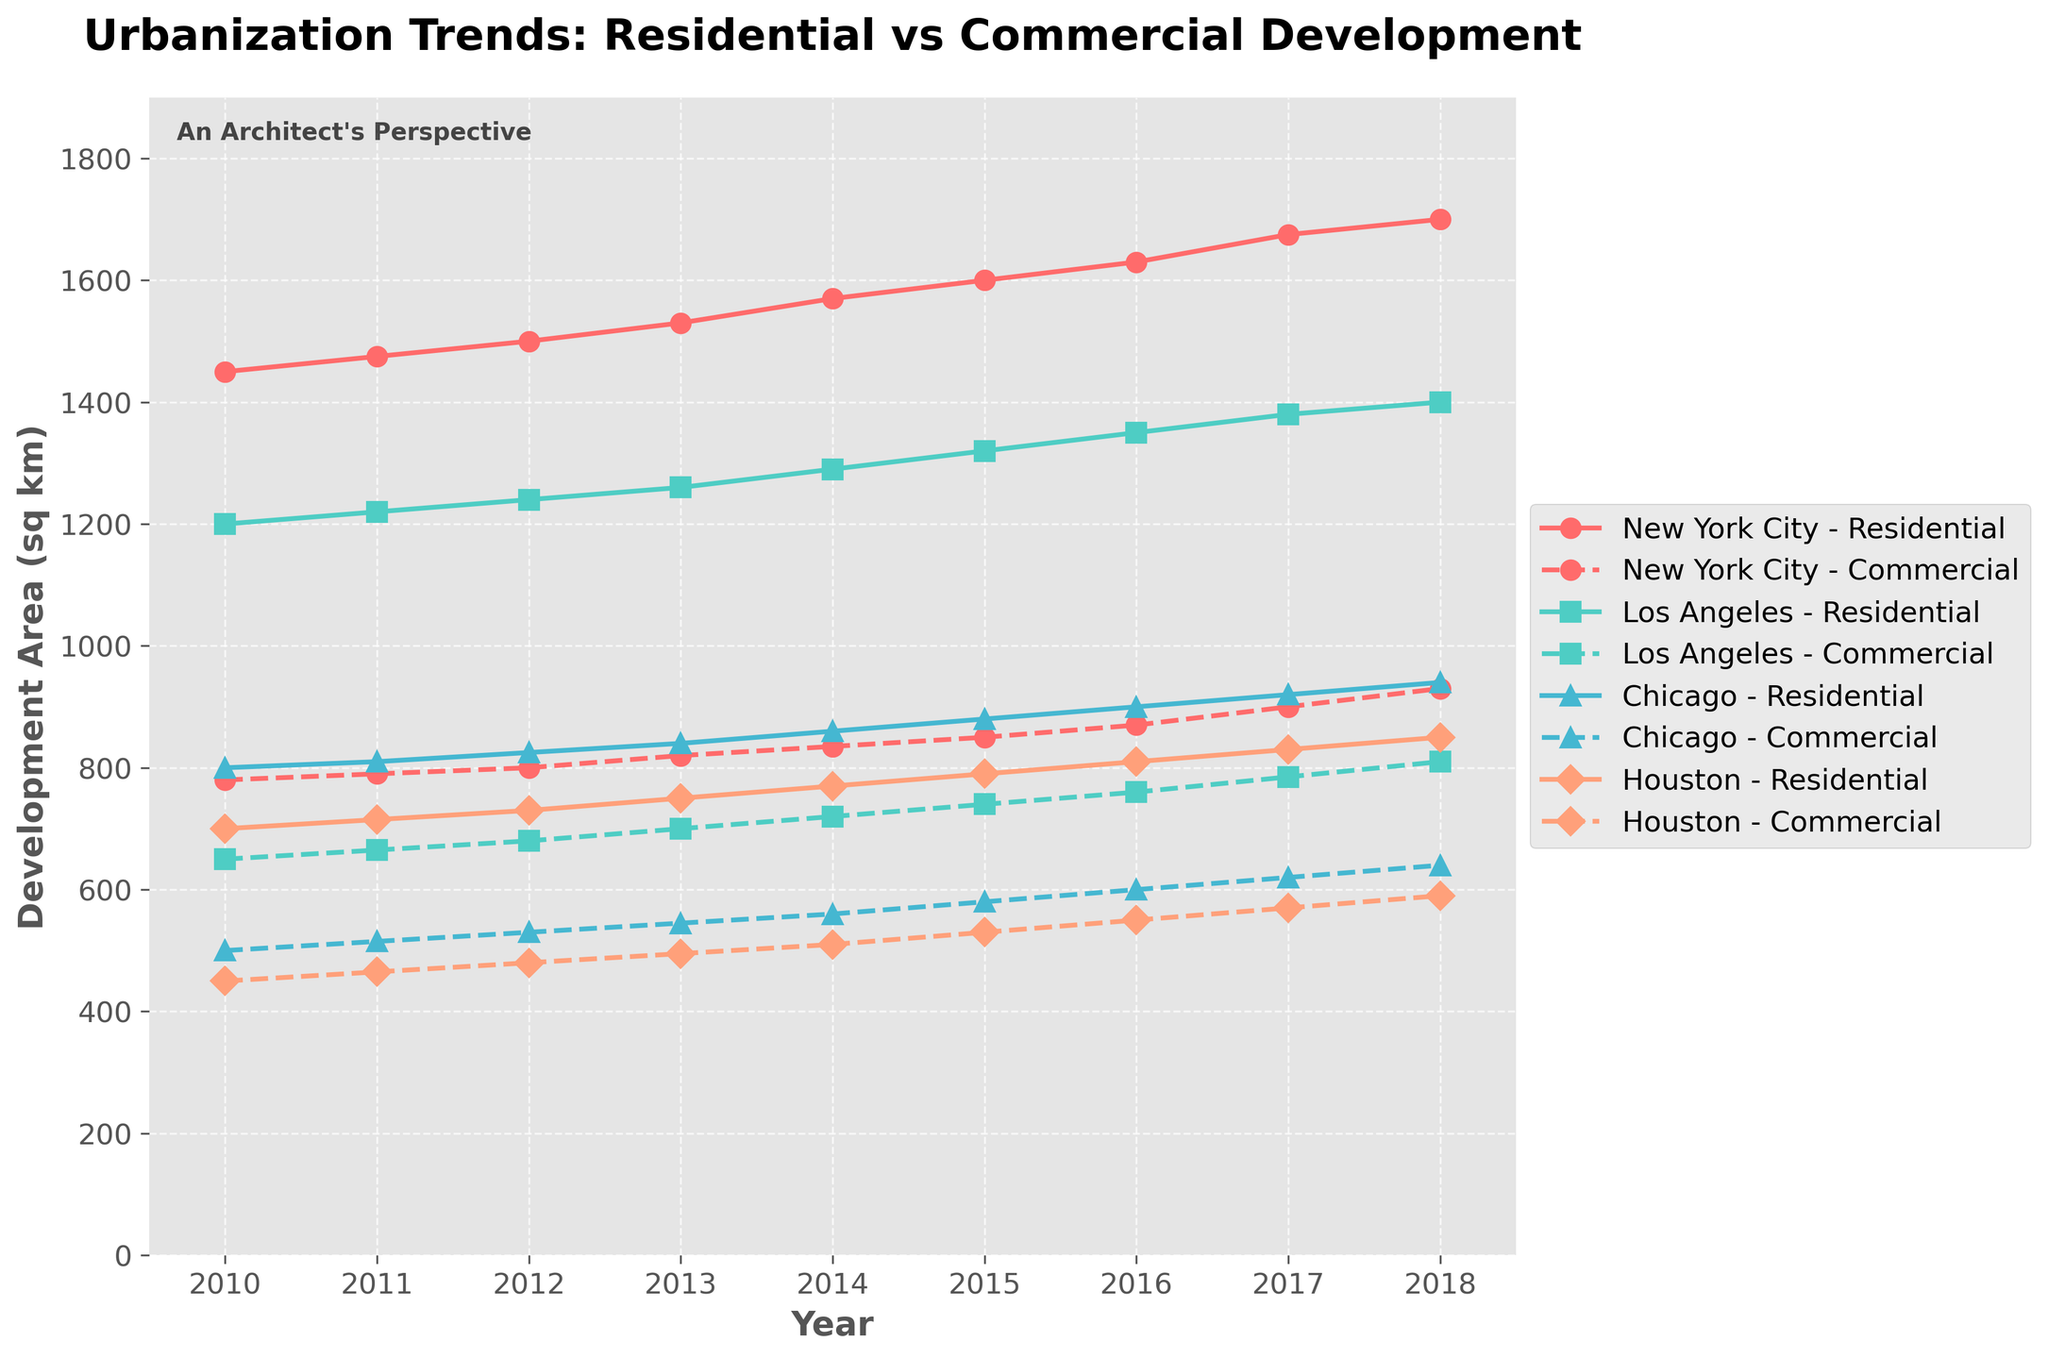What is the title of the figure? The title of the figure is located at the top and is usually the largest text in a bold font. It describes the content and purpose of the figure.
Answer: Urbanization Trends: Residential vs Commercial Development Between 2010 and 2018, which city shows the highest increase in residential development? To determine this, observe the starting and ending values for residential development for each city over the indicated years and calculate the differences. For New York City: 1700 - 1450 = 250 sq km, Los Angeles: 1400 - 1200 = 200 sq km, Chicago: 940 - 800 = 140 sq km, Houston: 850 - 700 = 150 sq km. New York City shows the highest increase.
Answer: New York City Which city had the least commercial development in 2018? Look at the end points of the dashed lines representing commercial development in 2018 for each city. Compare the values visually. For New York City: 930 sq km, Los Angeles: 810 sq km, Chicago: 640 sq km, Houston: 590 sq km.
Answer: Houston What is the combined total of commercial development (in sq km) in Chicago for the years 2015 and 2016? Add the values of commercial development for Chicago in 2015 and 2016. For 2015: 580 sq km, and for 2016: 600 sq km. The sum is 580 + 600 = 1180 sq km.
Answer: 1180 sq km In which year did Houston surpass 600 sq km of residential development? Look for the year where the residential development line for Houston first crosses the 600 sq km mark. This happens in 2016, as the value reaches 810 sq km.
Answer: 2016 How does the commercial development trend in New York City compare to Los Angeles from 2010 to 2018? Compare the slope (rate of change) of the dashed commercial development lines for New York City and Los Angeles. Both show an increasing trend, but New York City starts higher and increases at a faster rate.
Answer: Faster increase in New York City What is the difference in residential development between Los Angeles and Chicago in 2018? Find the residential development values for both cities in 2018 and calculate the difference. For Los Angeles: 1400 sq km, and for Chicago: 940 sq km. The difference is 1400 - 940 = 460 sq km.
Answer: 460 sq km Which city showed the most consistent increase in both residential and commercial development? Examine the plots for all cities and look for a city where both residential and commercial development lines are smooth and steadily increasing. New York City and Los Angeles show consistent increases, but New York City's lines are smoother and more consistent.
Answer: New York City 